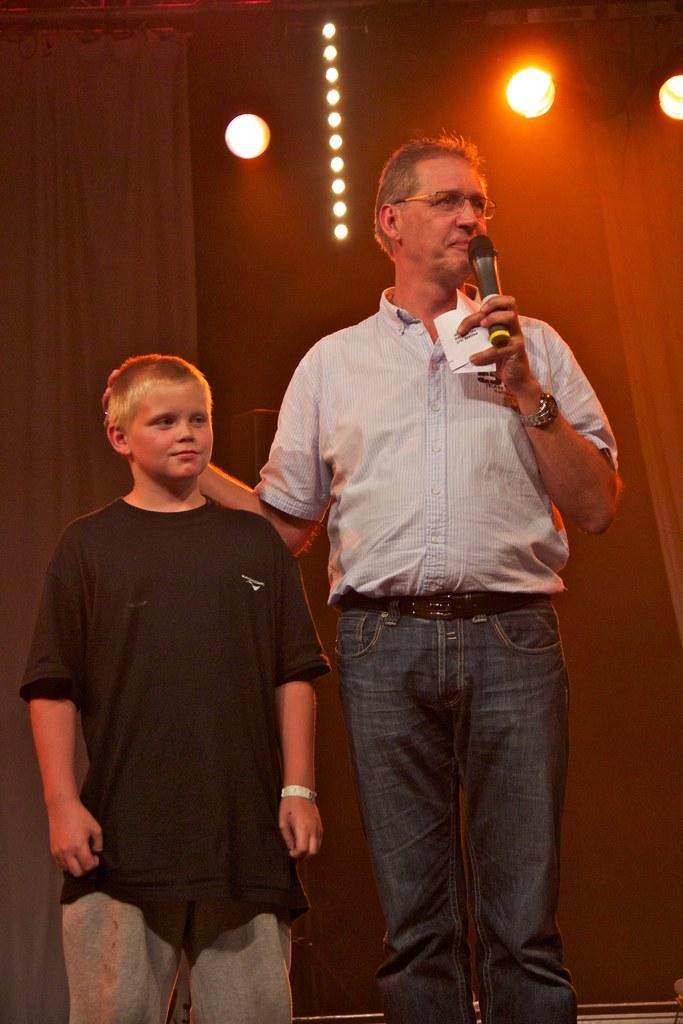Who is present in the image? There is a boy and a man in the image. What is the man holding in the image? The man is holding a microphone. What is the man doing in the image? The man is speaking. How many lights can be seen in the image? There are three lights visible in the image. What type of dust can be seen floating around the boy in the image? There is no dust visible in the image; it appears to be a clean environment. 